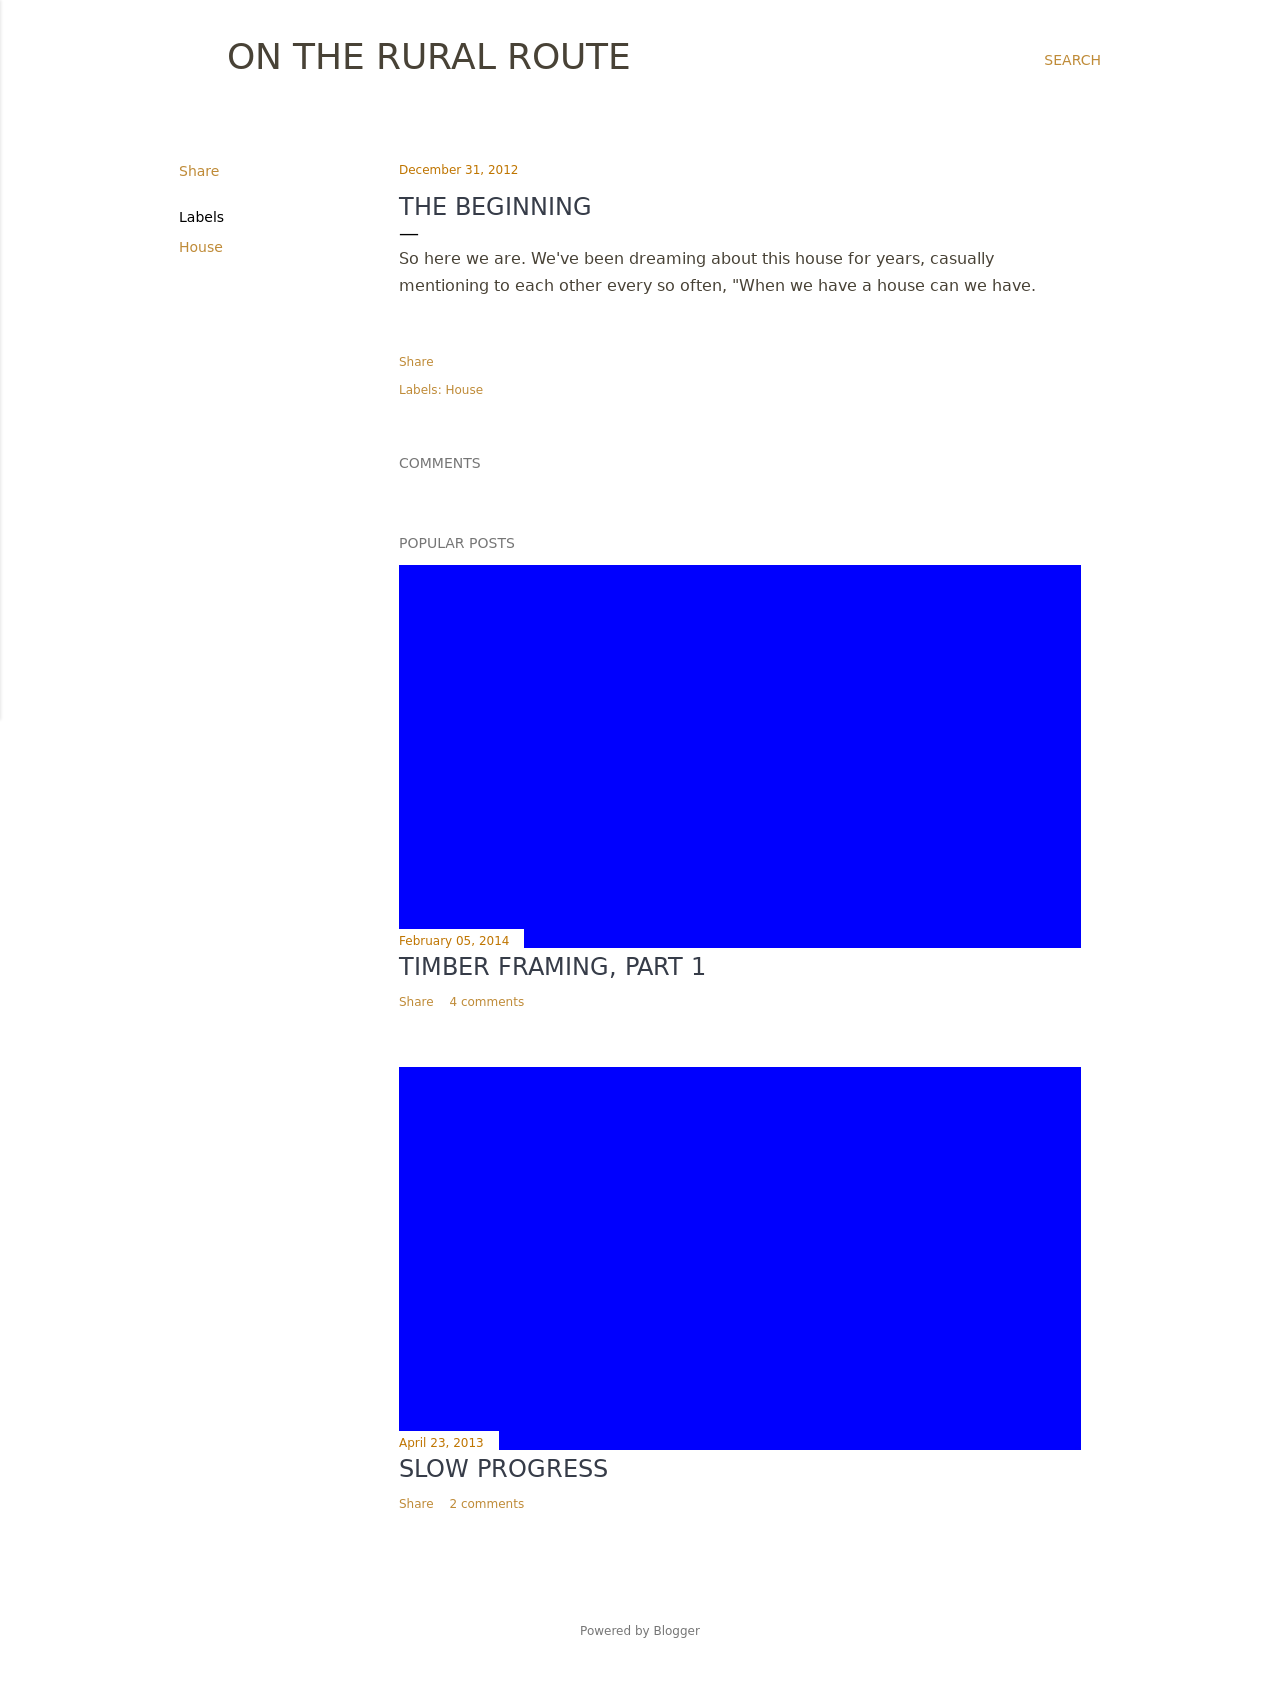How can I incorporate responsive design to ensure the website depicted accommodates different device sizes? To ensure the website is responsive, utilize CSS media queries to adjust styles based on the device's screen size. Use percentages for width and set max-width for images to ensure they scale down on smaller screens. Including a viewport meta tag in your HTML head can also enhance responsiveness, ensuring layout scales properly. 